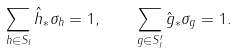Convert formula to latex. <formula><loc_0><loc_0><loc_500><loc_500>\sum _ { h \in S _ { I } } \hat { h } _ { \ast } \sigma _ { h } = 1 , \quad \sum _ { g \in S _ { I } ^ { \prime } } \hat { g } _ { \ast } \sigma _ { g } = 1 .</formula> 